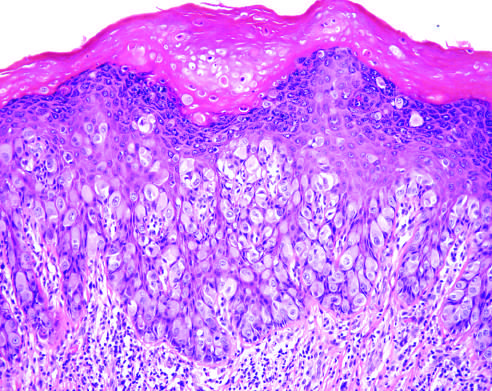what are present in the underlying dermis?
Answer the question using a single word or phrase. Chronic inflammatory cells 